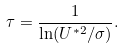<formula> <loc_0><loc_0><loc_500><loc_500>\tau = \frac { 1 } { \ln ( U ^ { * 2 } / \sigma ) } .</formula> 